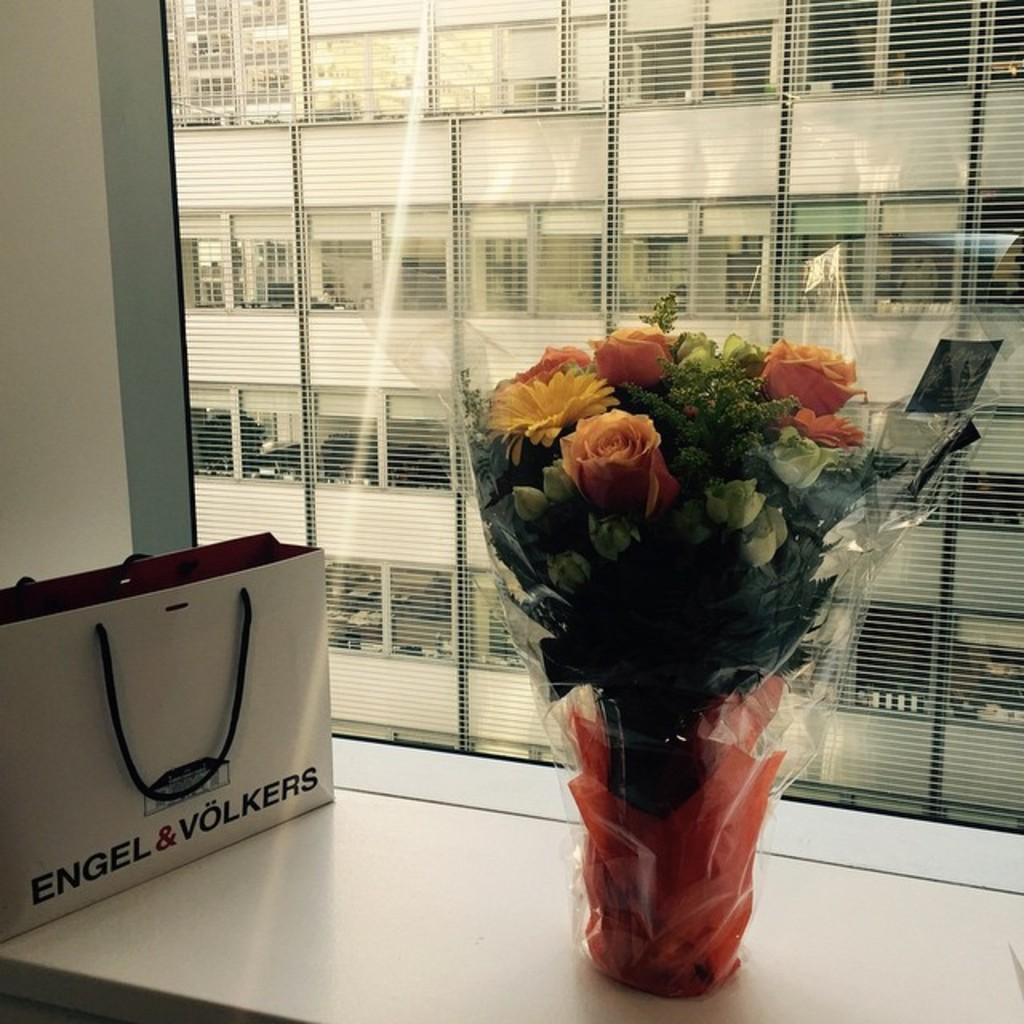What is the primary color of the surface in the image? The primary color of the surface in the image is white. What is placed on top of the white surface? There is a cover and a flower bouquet on the white surface. What can be seen in the background of the image? There is a window in the background of the image. What is visible through the window? A building with pillars is visible through the window. What type of secretary is present in the image? There is no secretary present in the image. What kind of society is depicted in the image? The image does not depict any society; it features a white surface with a cover and a flower bouquet, along with a window and a building with pillars in the background. 